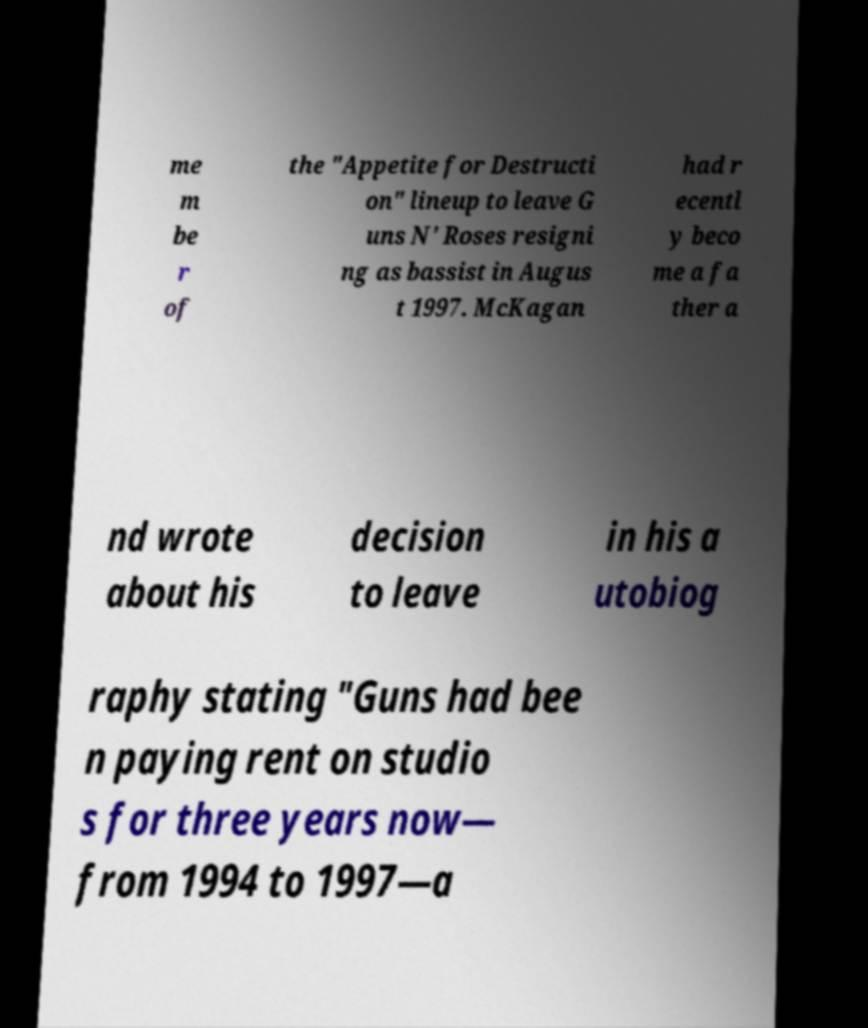Could you assist in decoding the text presented in this image and type it out clearly? me m be r of the "Appetite for Destructi on" lineup to leave G uns N' Roses resigni ng as bassist in Augus t 1997. McKagan had r ecentl y beco me a fa ther a nd wrote about his decision to leave in his a utobiog raphy stating "Guns had bee n paying rent on studio s for three years now— from 1994 to 1997—a 